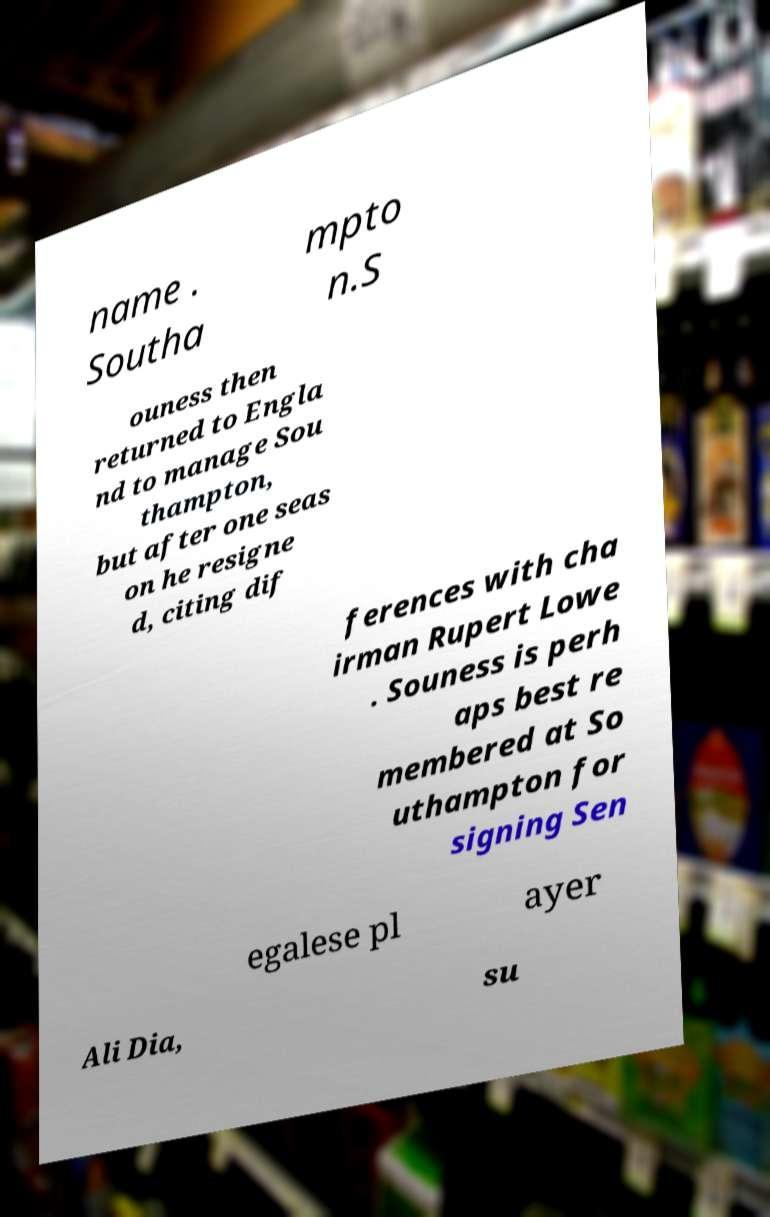Can you accurately transcribe the text from the provided image for me? name . Southa mpto n.S ouness then returned to Engla nd to manage Sou thampton, but after one seas on he resigne d, citing dif ferences with cha irman Rupert Lowe . Souness is perh aps best re membered at So uthampton for signing Sen egalese pl ayer Ali Dia, su 